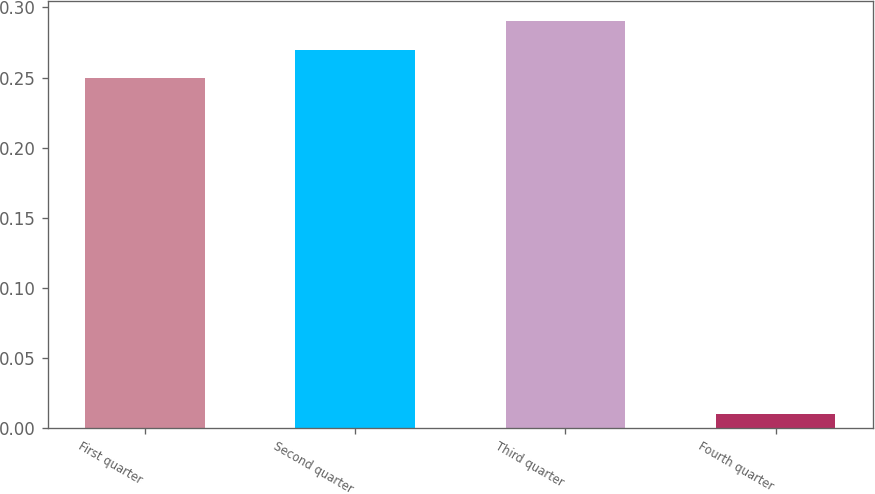Convert chart. <chart><loc_0><loc_0><loc_500><loc_500><bar_chart><fcel>First quarter<fcel>Second quarter<fcel>Third quarter<fcel>Fourth quarter<nl><fcel>0.25<fcel>0.27<fcel>0.29<fcel>0.01<nl></chart> 